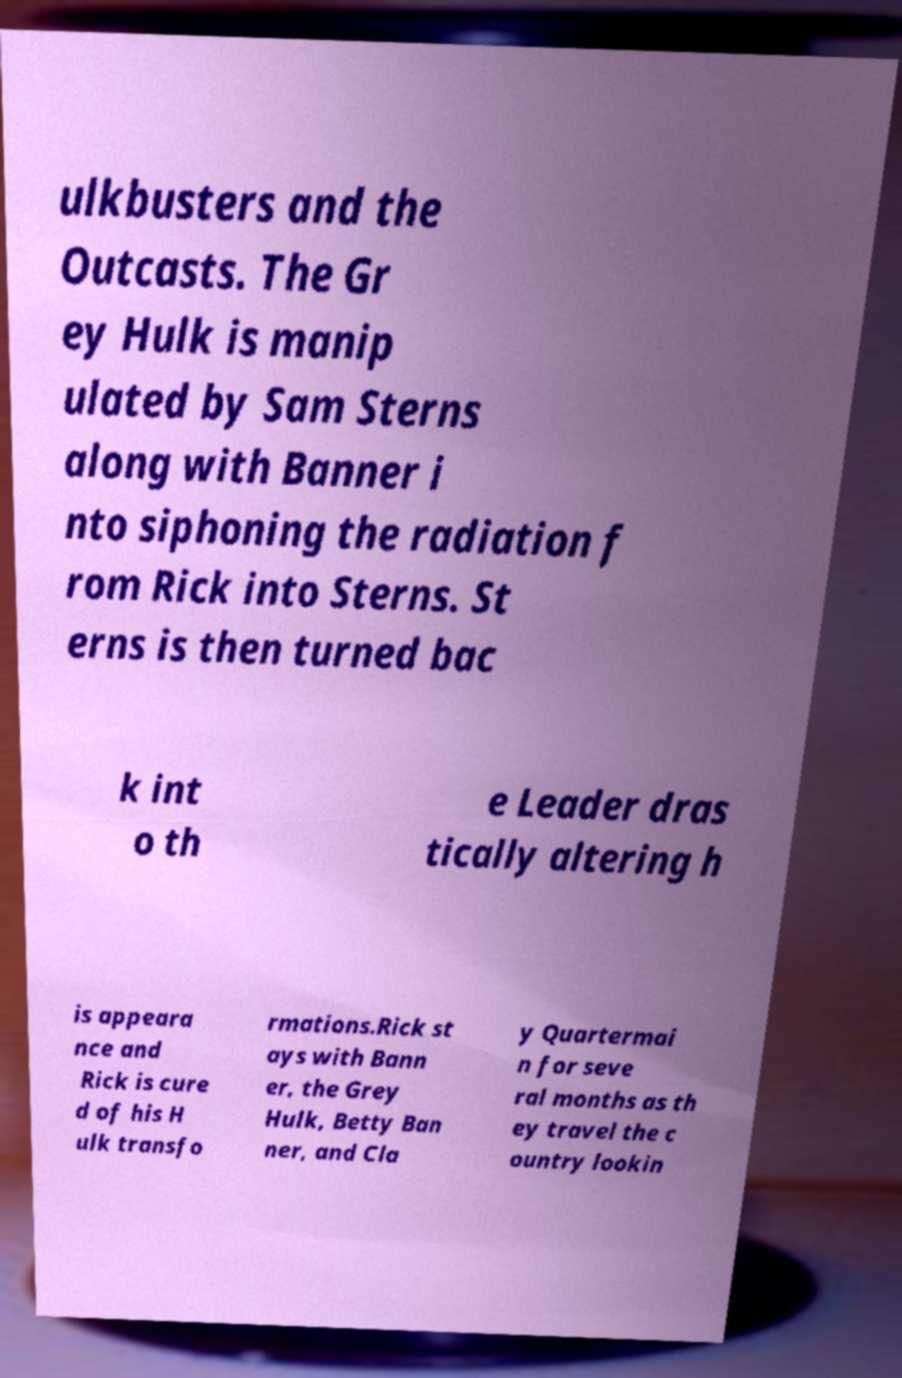Please identify and transcribe the text found in this image. ulkbusters and the Outcasts. The Gr ey Hulk is manip ulated by Sam Sterns along with Banner i nto siphoning the radiation f rom Rick into Sterns. St erns is then turned bac k int o th e Leader dras tically altering h is appeara nce and Rick is cure d of his H ulk transfo rmations.Rick st ays with Bann er, the Grey Hulk, Betty Ban ner, and Cla y Quartermai n for seve ral months as th ey travel the c ountry lookin 